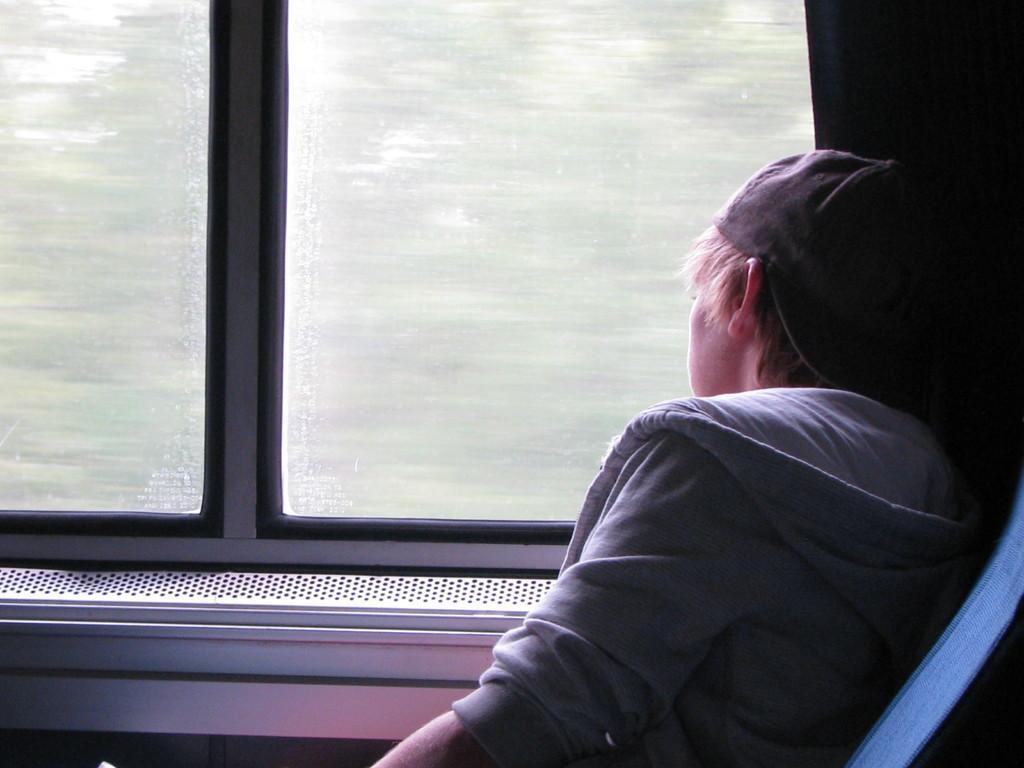Can you describe this image briefly? This image is an inside view of a train. On the right side of the image we can see a person is sitting. In the background of the image we can see window, cloth. 